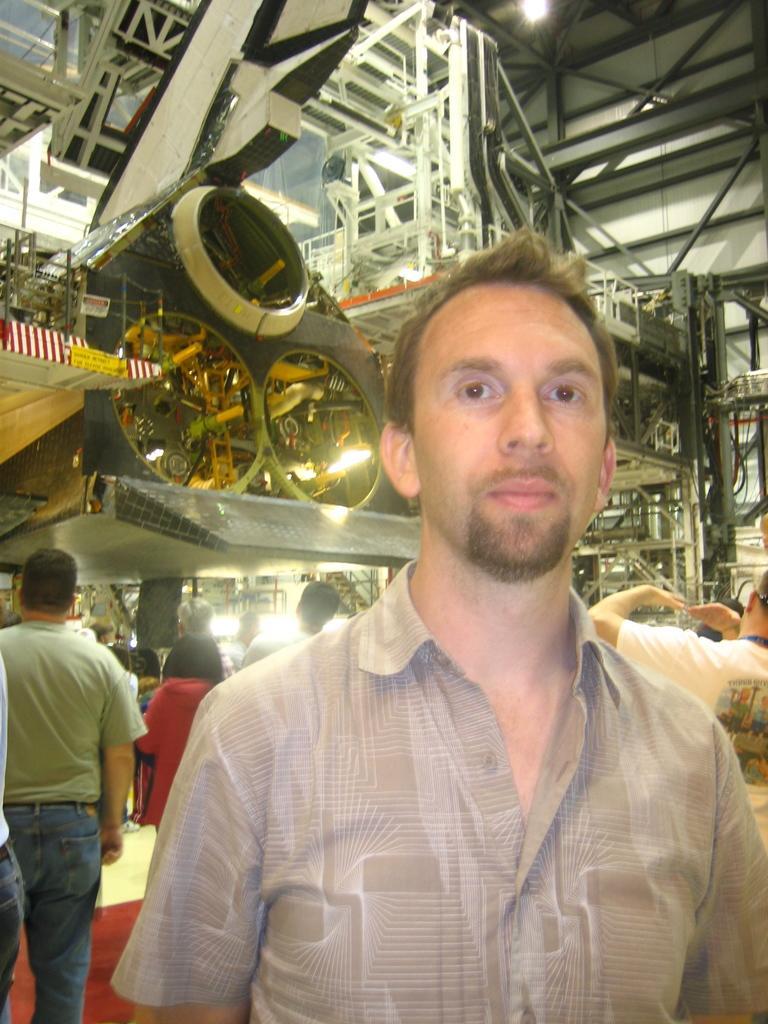Could you give a brief overview of what you see in this image? In this image we can see there are a few people standing in the auditorium. 